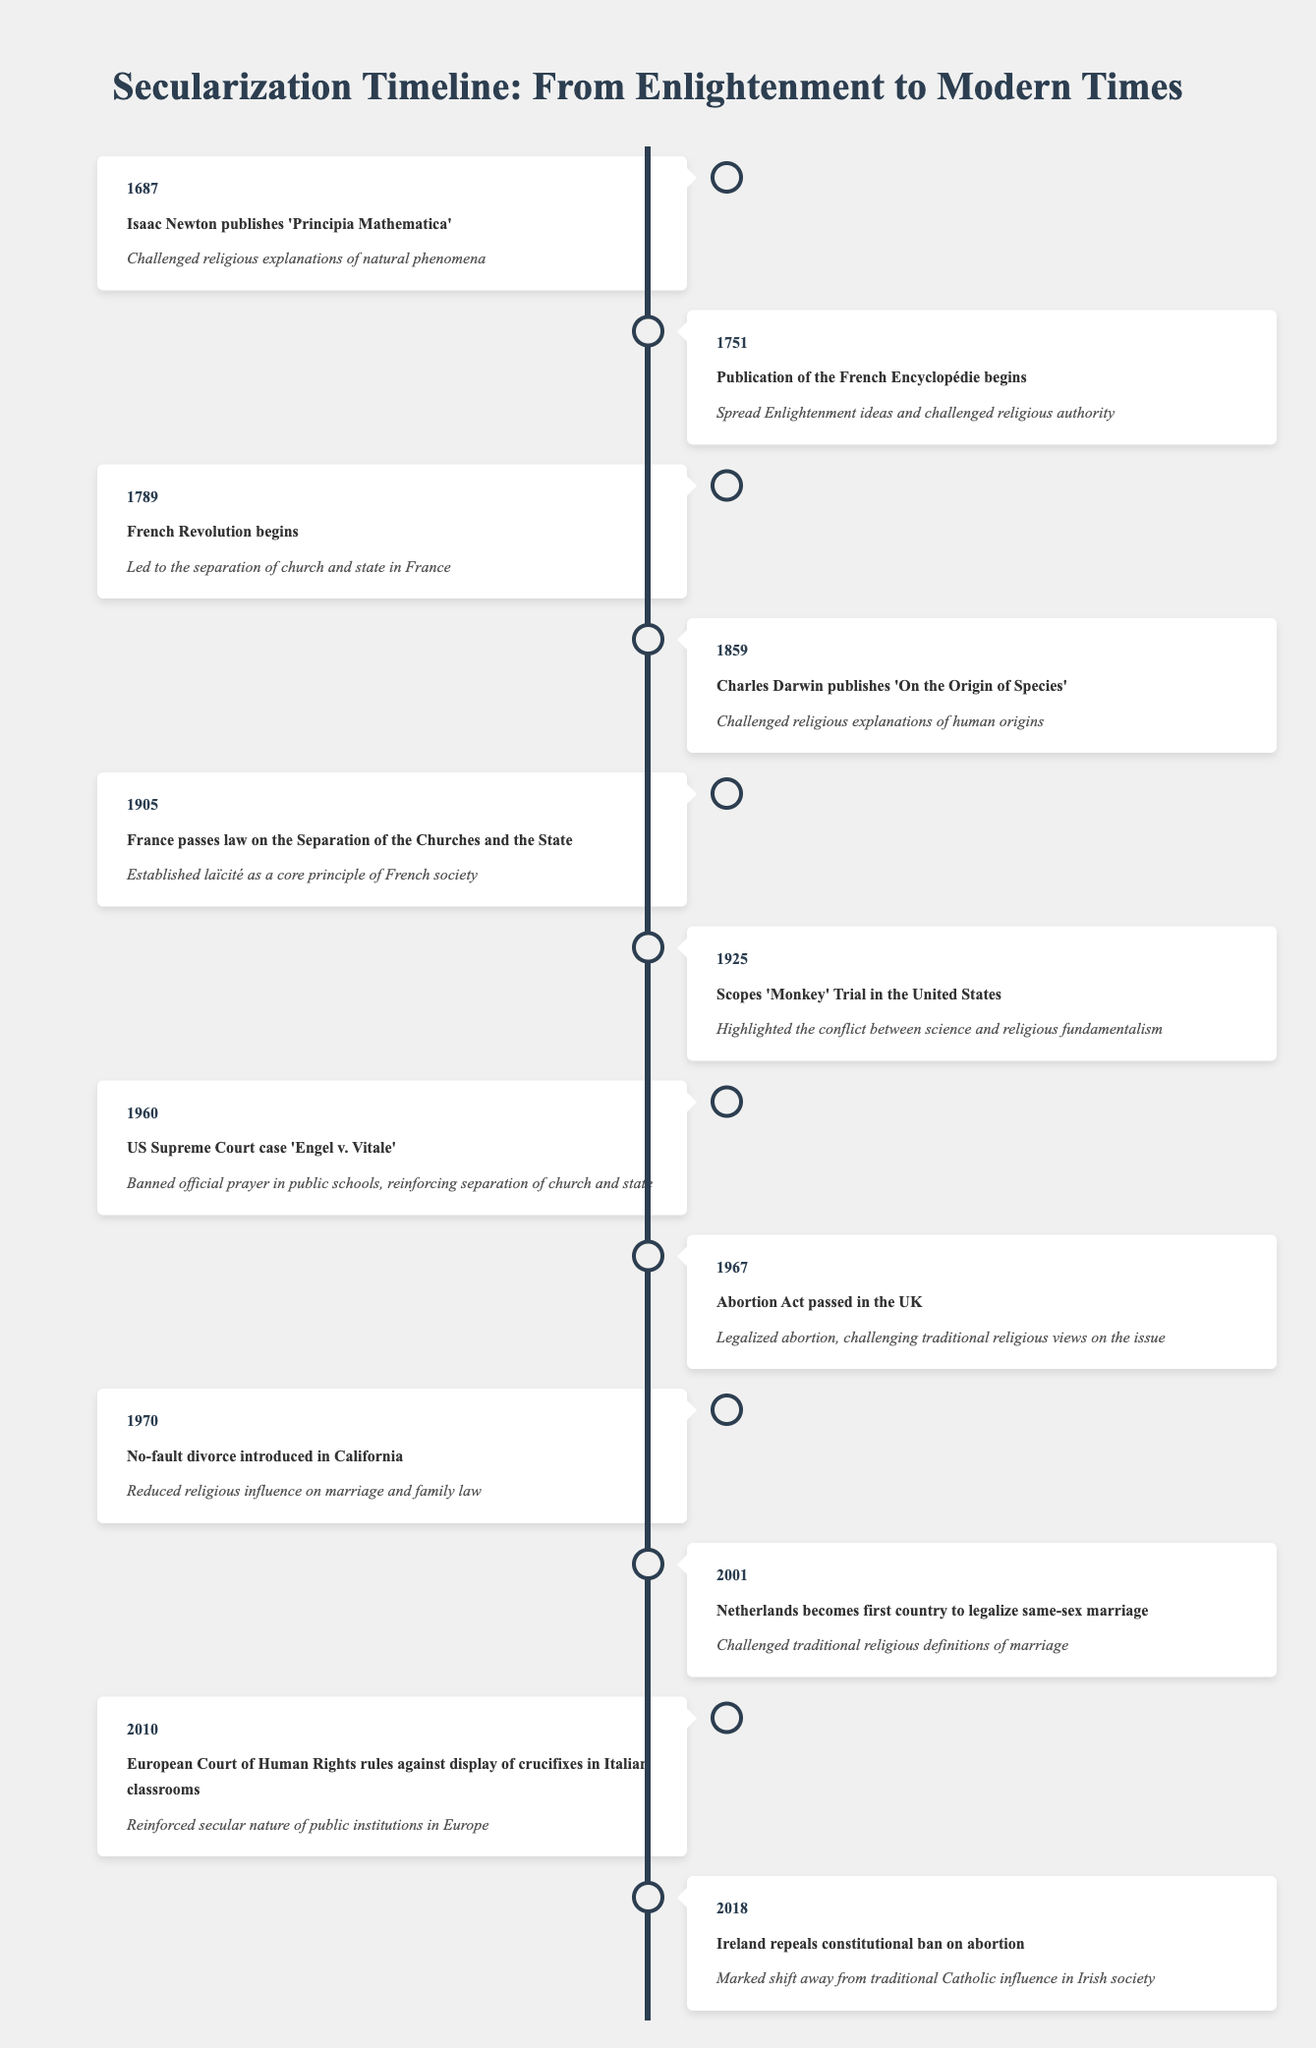What year did Isaac Newton publish 'Principia Mathematica'? The table shows the year associated with the event of Isaac Newton publishing 'Principia Mathematica' as 1687. Therefore, we can directly reference this information to answer the question.
Answer: 1687 What event occurred in 1789? According to the table, the event that took place in 1789 is the beginning of the French Revolution. This is stated directly in the corresponding row for that year.
Answer: French Revolution begins Which event marked a shift in societal views on marriage by legalizing same-sex marriage? In 2001, the Netherlands became the first country to legalize same-sex marriage, as indicated in the table. This act directly challenged traditional religious definitions of marriage.
Answer: Netherlands legalizes same-sex marriage How many years separate the publication of 'On the Origin of Species' from the passing of the law on the Separation of the Churches and the State in France? The publication of 'On the Origin of Species' occurred in 1859, and the law on the Separation of the Churches and the State was passed in 1905. The difference in years is calculated as 1905 - 1859 = 46 years.
Answer: 46 years Is it true that the Scopes 'Monkey' Trial occurred before the US Supreme Court case 'Engel v. Vitale'? The table lists the Scopes 'Monkey' Trial in 1925 and the US Supreme Court case 'Engel v. Vitale' in 1960. Since 1925 is earlier than 1960, the statement is true.
Answer: Yes What is the total number of events listed in the timeline that occurred after 1960? By counting the events in the timeline that have years greater than 1960, we find the actions in 1967, 1970, 2001, 2010, and 2018. That makes a total of five events.
Answer: 5 events Which event indicated a significant legal change regarding abortion in Ireland? The table shows that in 2018, Ireland repealed a constitutional ban on abortion, which signifies a significant legal change regarding traditional Catholic influence on the issue in Irish society.
Answer: Ireland repeals ban on abortion What was the significance of the year 1905 in the context of secularization in France? In 1905, France passed a law on the Separation of the Churches and the State, which was a foundational development establishing laïcité as a core principle of French society. This underscores the shift towards secularization.
Answer: Established laïcité in France What event in 1960 reinforced the separation of church and state in the United States? The event in 1960 that reinforced the separation of church and state was the US Supreme Court case 'Engel v. Vitale', which banned official prayer in public schools. This demonstrates a significant move toward secular governance.
Answer: Engel v. Vitale decision 